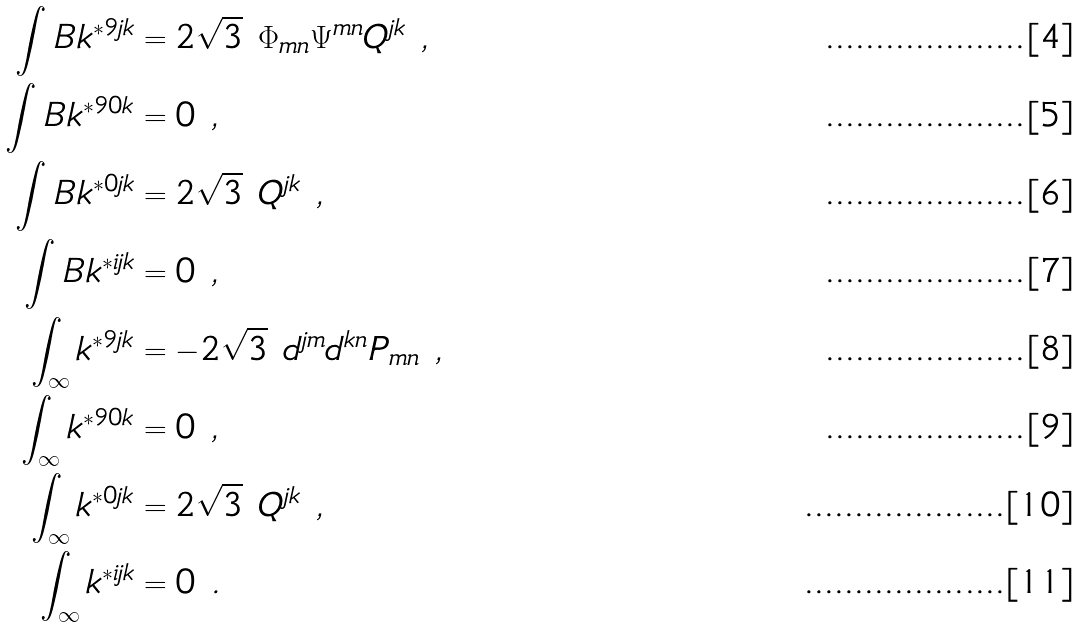<formula> <loc_0><loc_0><loc_500><loc_500>\int _ { \ } B k ^ { * 9 j k } & = 2 \sqrt { 3 } \ \Phi _ { m n } \Psi ^ { m n } Q ^ { j k } \ , \\ \int _ { \ } B k ^ { * 9 0 k } & = 0 \ , \\ \int _ { \ } B k ^ { * 0 j k } & = 2 \sqrt { 3 } \ Q ^ { j k } \ , \\ \int _ { \ } B k ^ { * i j k } & = 0 \ , \\ \int _ { \infty } k ^ { * 9 j k } & = - 2 \sqrt { 3 } \ d ^ { j m } d ^ { k n } P _ { m n } \ , \\ \int _ { \infty } k ^ { * 9 0 k } & = 0 \ , \\ \int _ { \infty } k ^ { * 0 j k } & = 2 \sqrt { 3 } \ Q ^ { j k } \ , \\ \int _ { \infty } k ^ { * i j k } & = 0 \ .</formula> 